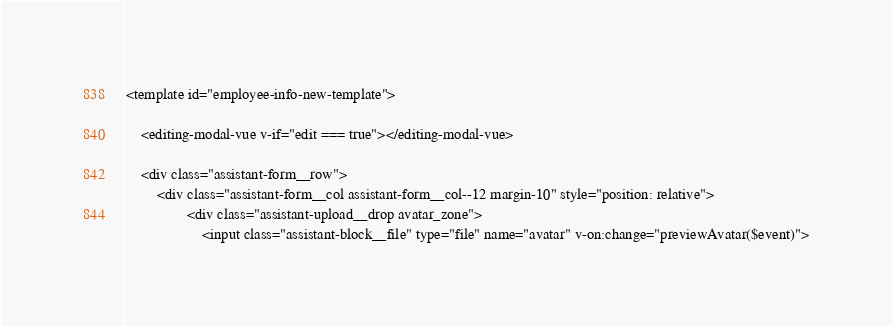Convert code to text. <code><loc_0><loc_0><loc_500><loc_500><_PHP_><template id="employee-info-new-template">

    <editing-modal-vue v-if="edit === true"></editing-modal-vue>

    <div class="assistant-form__row">
        <div class="assistant-form__col assistant-form__col--12 margin-10" style="position: relative">
                <div class="assistant-upload__drop avatar_zone">
                    <input class="assistant-block__file" type="file" name="avatar" v-on:change="previewAvatar($event)"></code> 